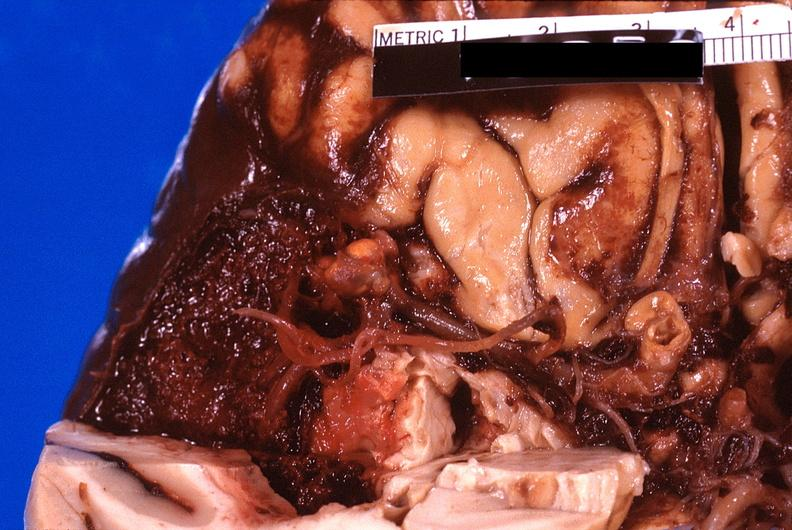does whipples disease show brain, subarachanoid hemorrhage due to ruptured aneurysm?
Answer the question using a single word or phrase. No 